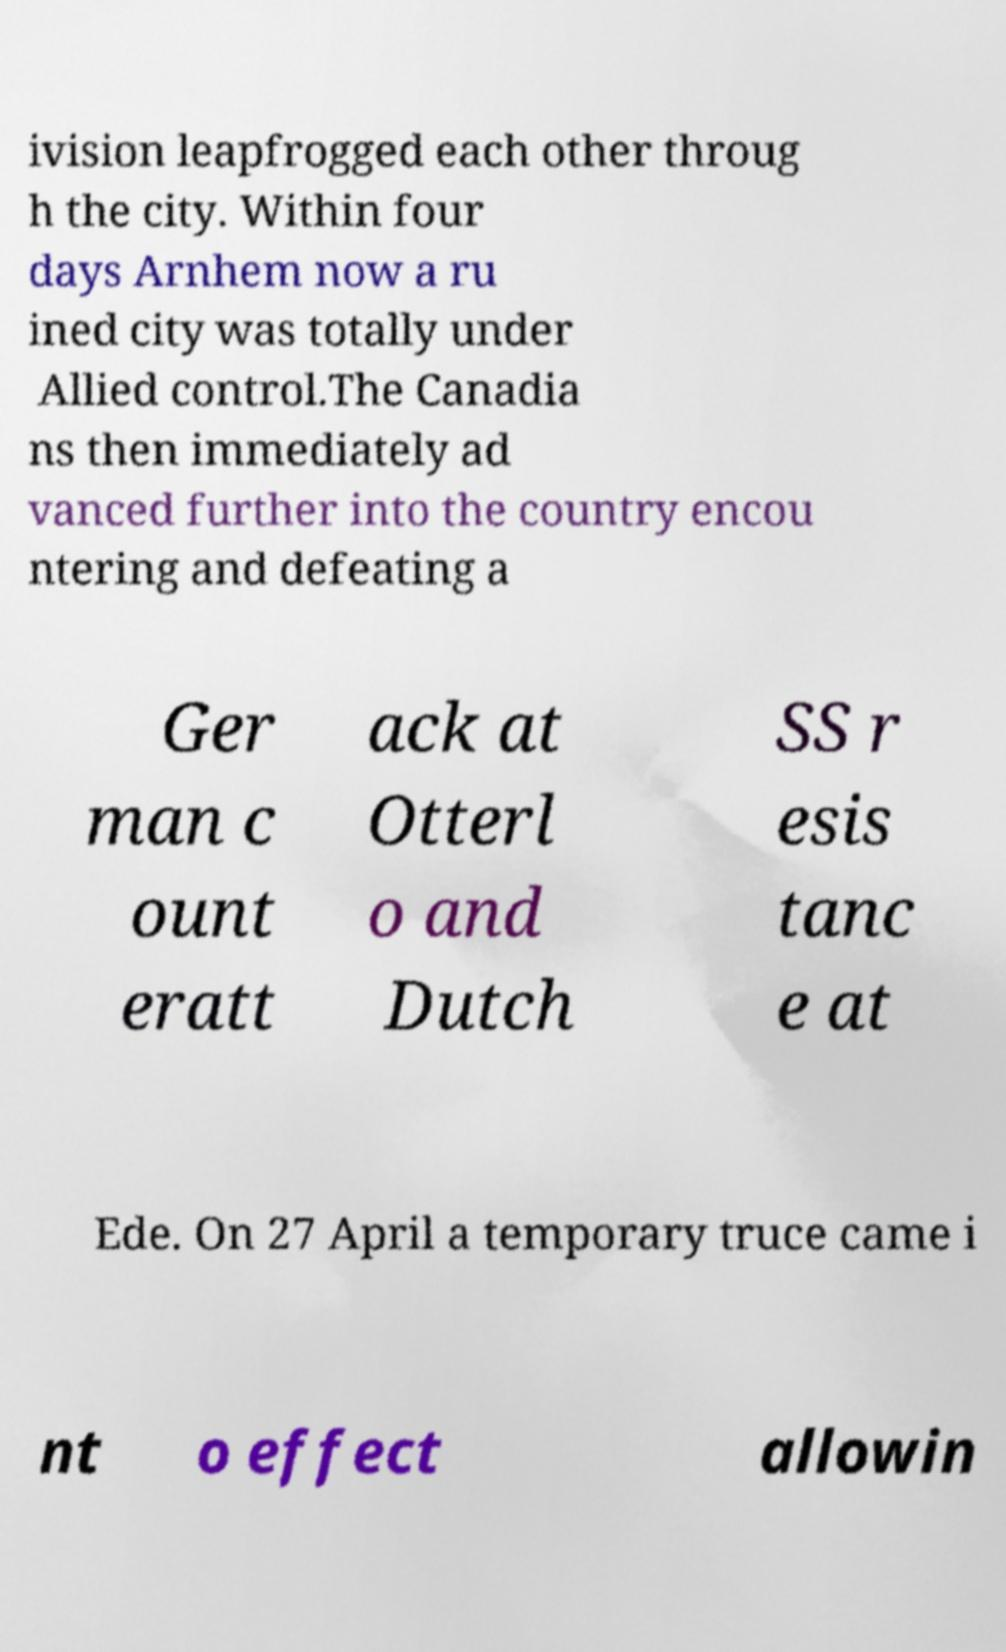Please identify and transcribe the text found in this image. ivision leapfrogged each other throug h the city. Within four days Arnhem now a ru ined city was totally under Allied control.The Canadia ns then immediately ad vanced further into the country encou ntering and defeating a Ger man c ount eratt ack at Otterl o and Dutch SS r esis tanc e at Ede. On 27 April a temporary truce came i nt o effect allowin 